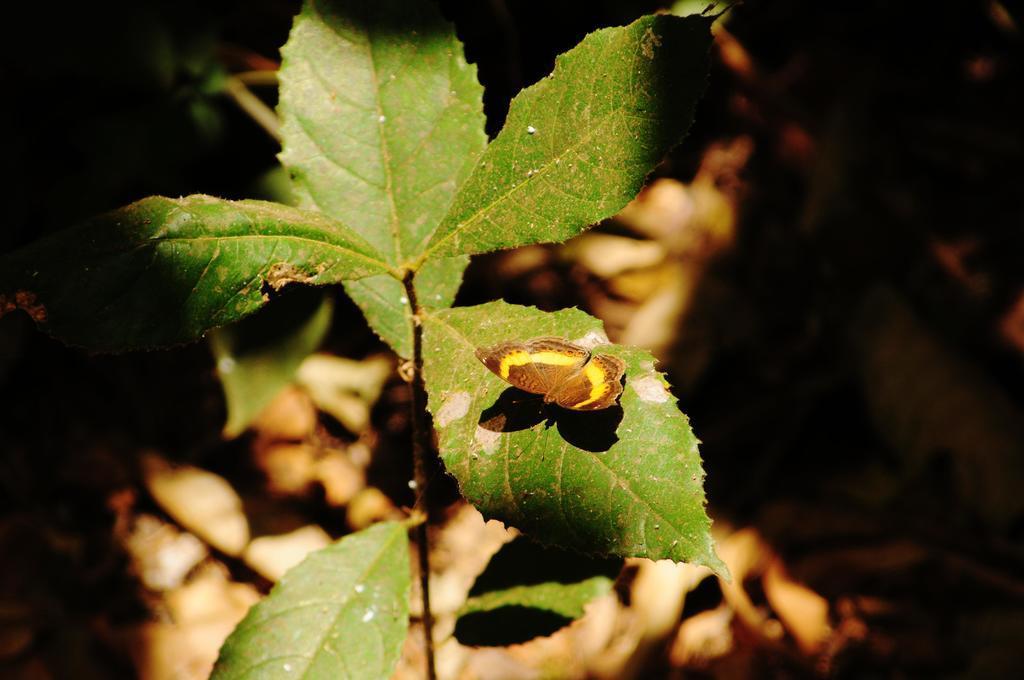Describe this image in one or two sentences. In the middle of the image, there is dust on the green color leaves of a plant. And the background is blurred. 